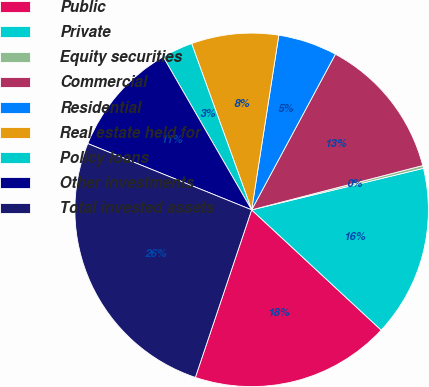<chart> <loc_0><loc_0><loc_500><loc_500><pie_chart><fcel>Public<fcel>Private<fcel>Equity securities<fcel>Commercial<fcel>Residential<fcel>Real estate held for<fcel>Policy loans<fcel>Other investments<fcel>Total invested assets<nl><fcel>18.25%<fcel>15.68%<fcel>0.26%<fcel>13.11%<fcel>5.4%<fcel>7.97%<fcel>2.83%<fcel>10.54%<fcel>25.96%<nl></chart> 